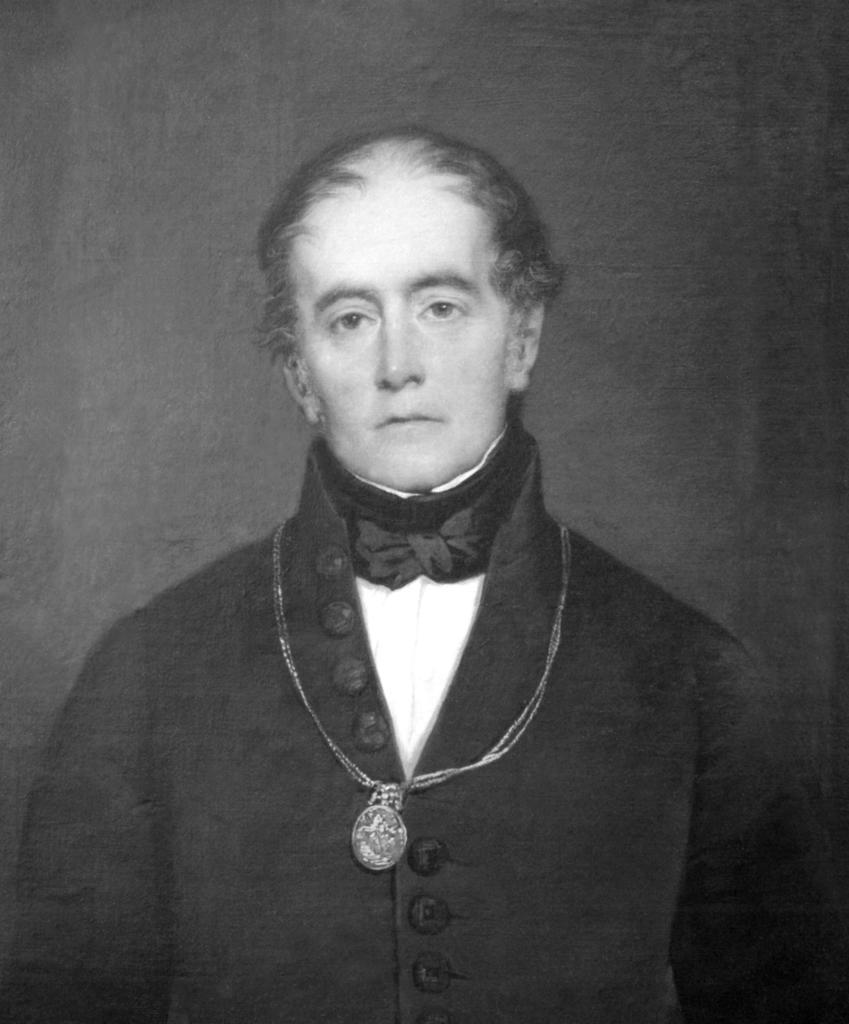Who is the main subject in the picture? There is a man in the picture. What is the man wearing? The man is wearing a black dress. What is the man doing in the picture? The man is standing and posing for a photograph. What letter is the man trying to balance on his nose in the image? There is no letter present in the image, and the man is not attempting to balance anything on his nose. 